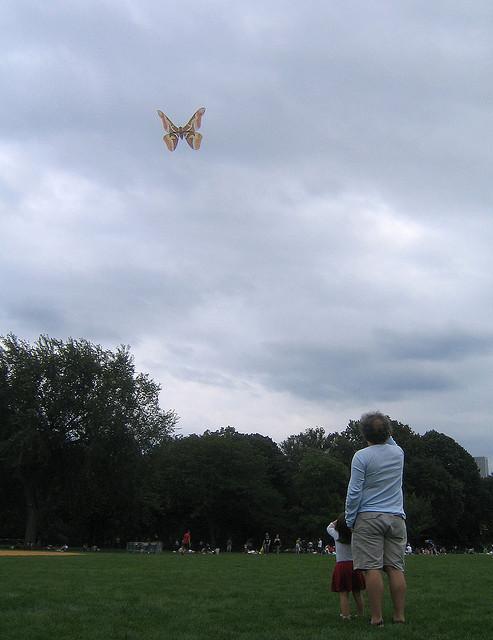How many people are in the picture?
Give a very brief answer. 2. 